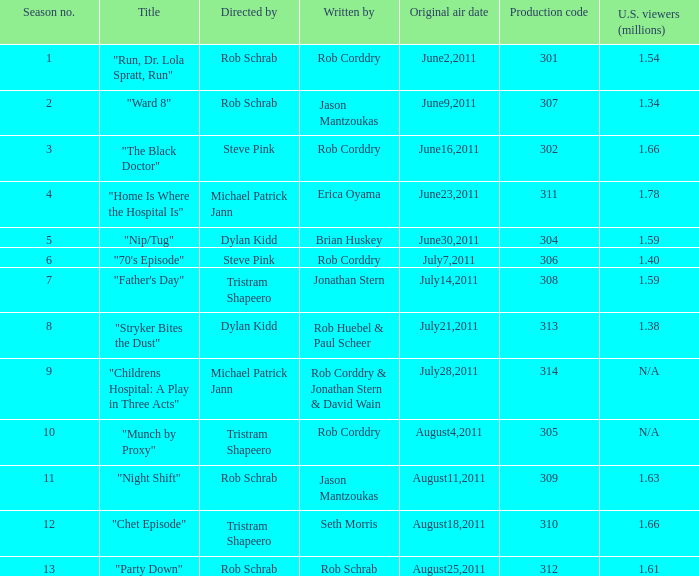Who directed the episode entitled "home is where the hospital is"? Michael Patrick Jann. 